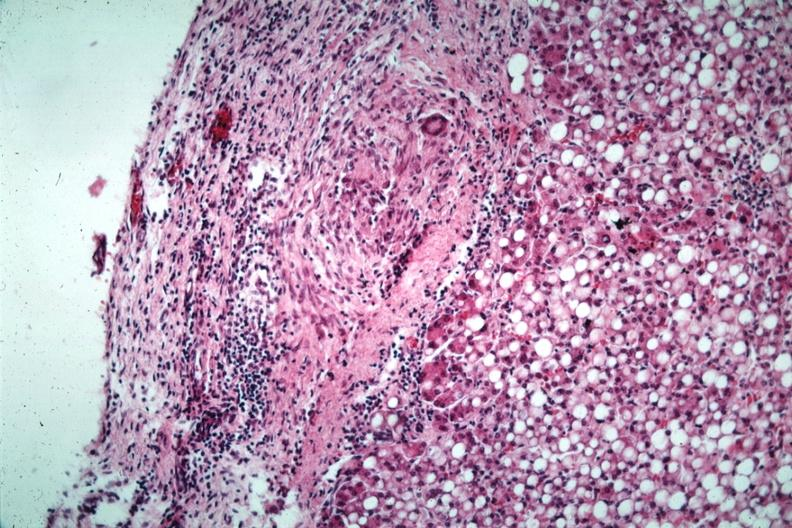has quite good liver marked fatty change?
Answer the question using a single word or phrase. Yes 